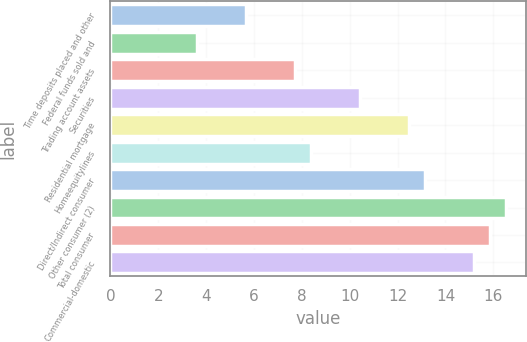<chart> <loc_0><loc_0><loc_500><loc_500><bar_chart><fcel>Time deposits placed and other<fcel>Federal funds sold and<fcel>Trading account assets<fcel>Securities<fcel>Residential mortgage<fcel>Homeequitylines<fcel>Direct/Indirect consumer<fcel>Other consumer (2)<fcel>Total consumer<fcel>Commercial-domestic<nl><fcel>5.66<fcel>3.62<fcel>7.7<fcel>10.42<fcel>12.46<fcel>8.38<fcel>13.14<fcel>16.54<fcel>15.86<fcel>15.18<nl></chart> 